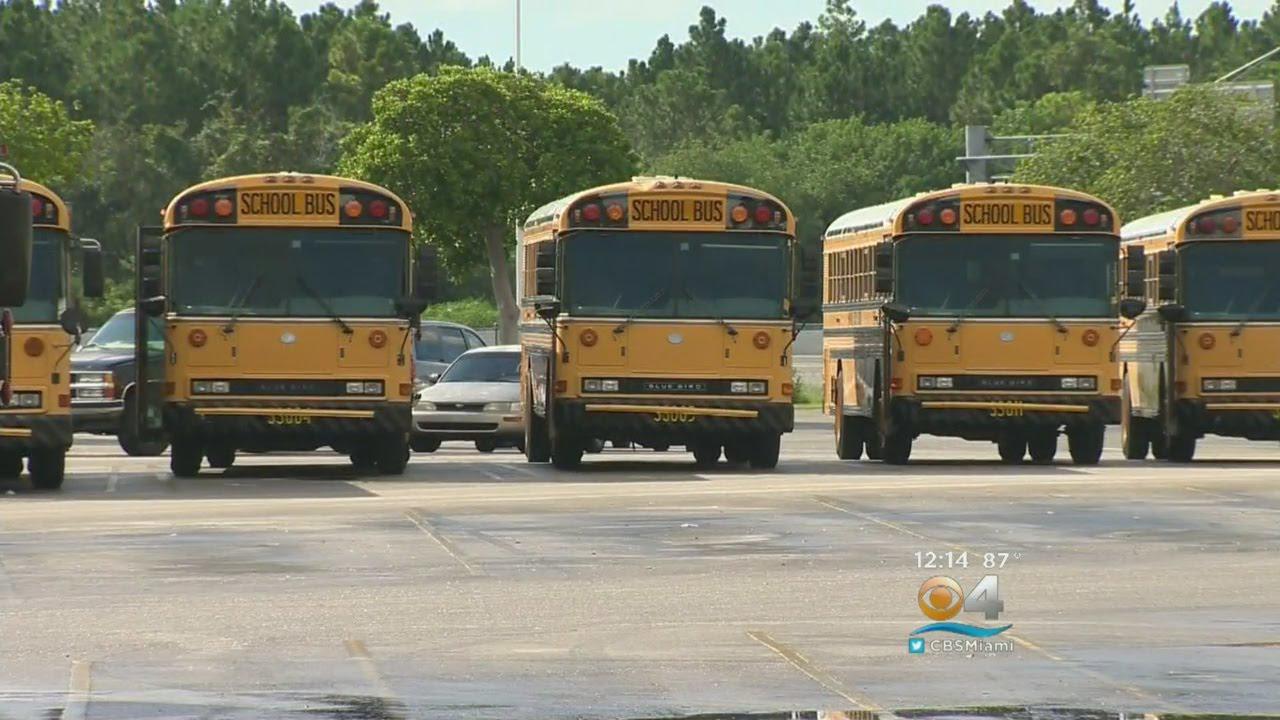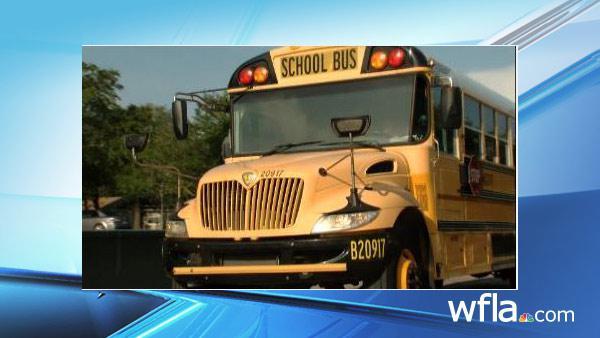The first image is the image on the left, the second image is the image on the right. For the images displayed, is the sentence "One image shows at least five school buses parked next to each other." factually correct? Answer yes or no. Yes. 